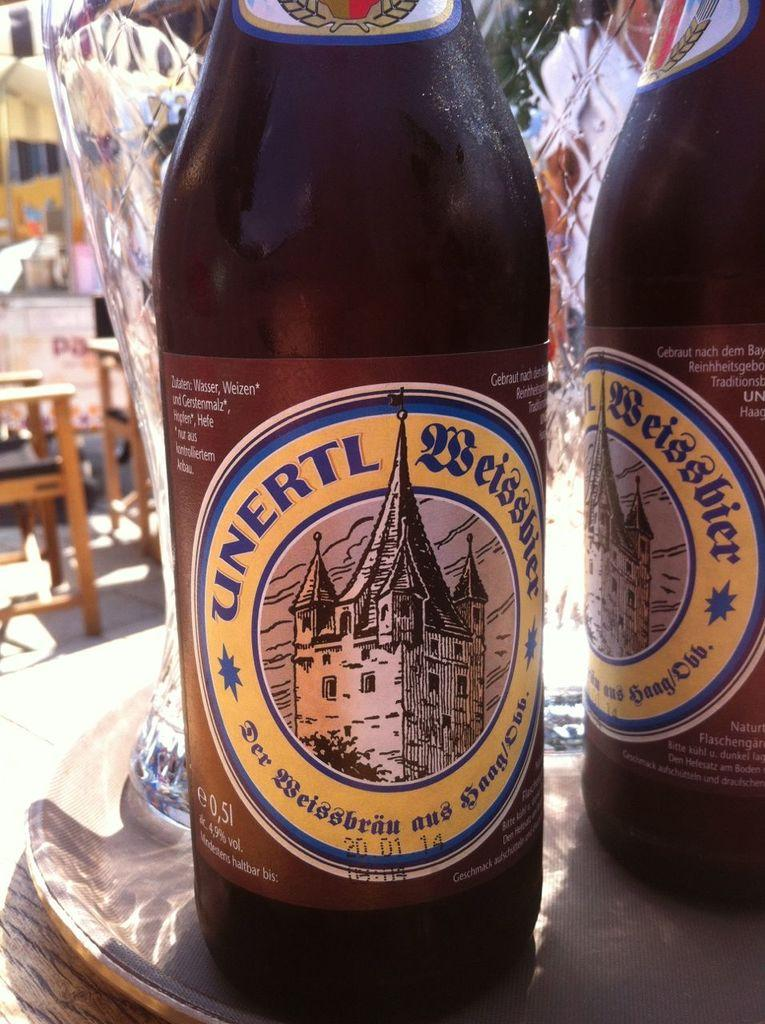<image>
Summarize the visual content of the image. Two brown bottles of German Weizen are on the tray on the table. 